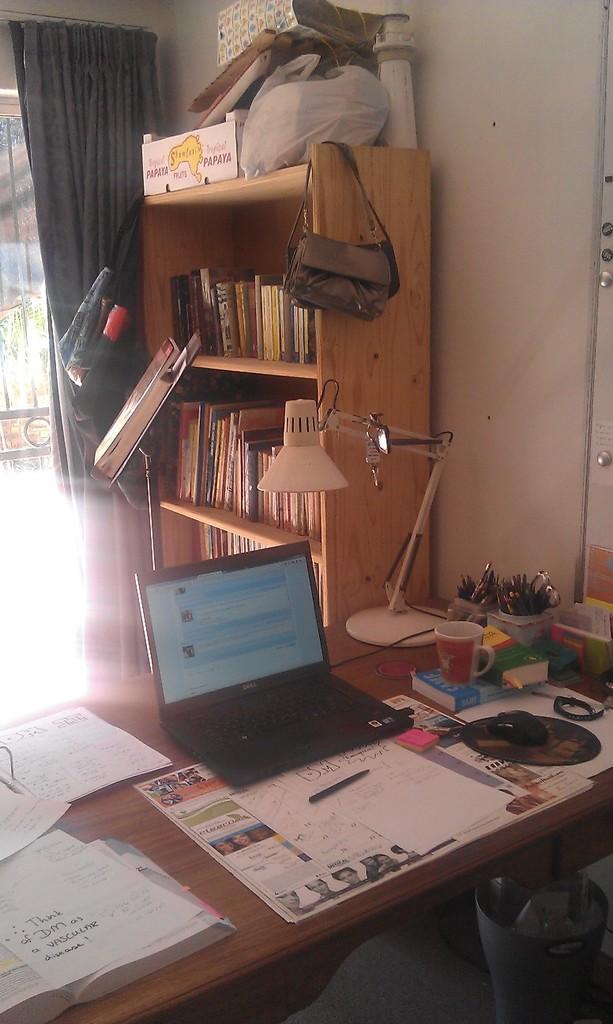Can you describe this image briefly? As we can see in the image there is a white color wall, curtain, track filled with books, handbag, box, cover and a table. On table there are papers, pen, laptop, books, glass and pens. 